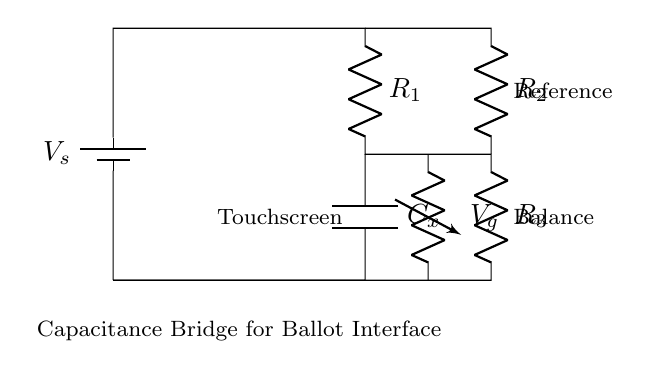What type of circuit is represented? The circuit is a capacitance bridge, which is specifically designed for measuring capacitance by balancing two legs of a circuit.
Answer: capacitance bridge What component is labeled as "C_x"? "C_x" represents the unknown capacitance in the circuit used for testing the touchscreen interface.
Answer: unknown capacitance How many resistors are present in the circuit? There are three resistors labeled R1, R2, and R3 in the circuit.
Answer: three What is the role of the battery? The battery provides the supply voltage, labeled as "V_s," which powers the circuit and allows for the measurements to be taken.
Answer: supply voltage What does the label "V_g" represent? "V_g" indicates the voltage across the gap, particularly in reference to measuring balance or potential differences in the circuit.
Answer: voltage across the gap Why is there a touchscreen labeled in the circuit? The touchscreen is indicated as the component under test, where the capacitance changes based on touch, which the bridge aims to measure.
Answer: component under test What is the purpose of the reference in this circuit? The reference in the circuit serves to create a standard for comparison with the unknown capacitance, aiding in achieving balance in the bridge.
Answer: standard for comparison 